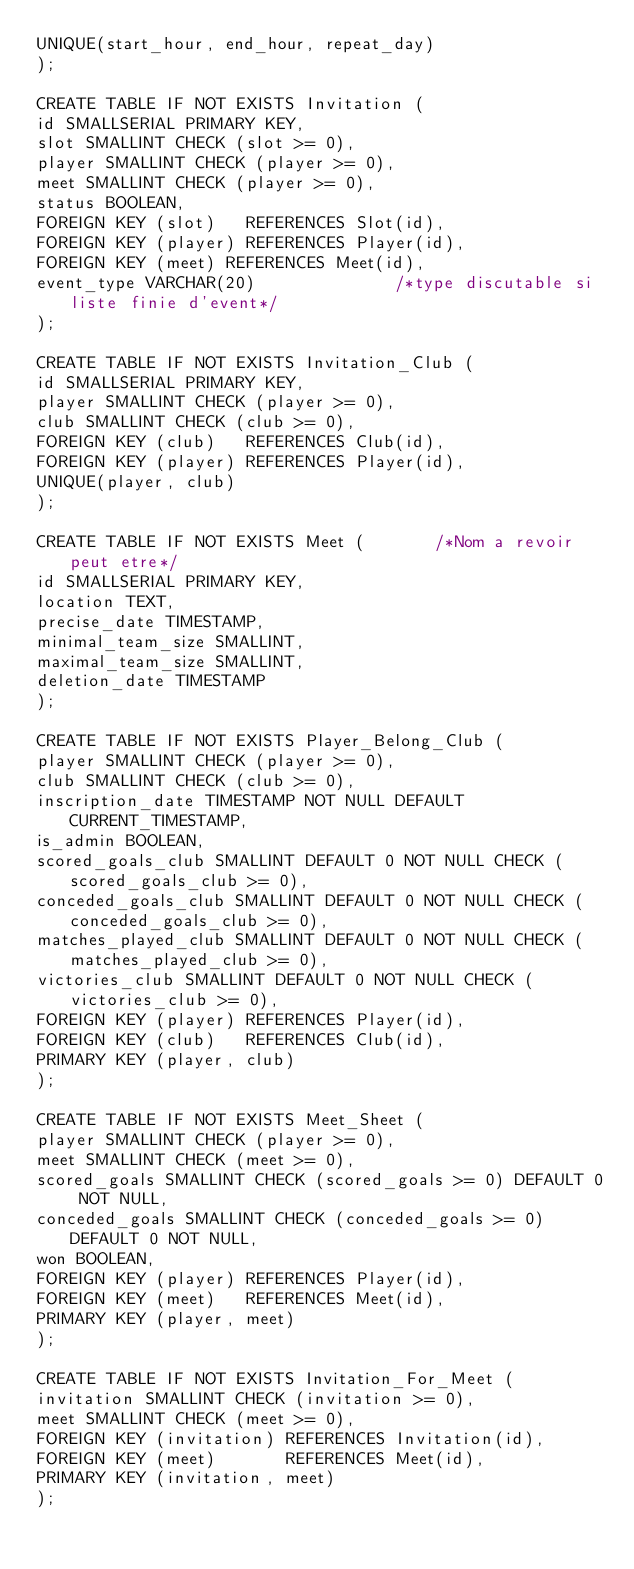<code> <loc_0><loc_0><loc_500><loc_500><_SQL_>UNIQUE(start_hour, end_hour, repeat_day)
);

CREATE TABLE IF NOT EXISTS Invitation (
id SMALLSERIAL PRIMARY KEY,
slot SMALLINT CHECK (slot >= 0),
player SMALLINT CHECK (player >= 0),
meet SMALLINT CHECK (player >= 0),
status BOOLEAN,
FOREIGN KEY (slot)   REFERENCES Slot(id),
FOREIGN KEY (player) REFERENCES Player(id),
FOREIGN KEY (meet) REFERENCES Meet(id),
event_type VARCHAR(20)  						/*type discutable si liste finie d'event*/
);

CREATE TABLE IF NOT EXISTS Invitation_Club (
id SMALLSERIAL PRIMARY KEY,
player SMALLINT CHECK (player >= 0),
club SMALLINT CHECK (club >= 0),
FOREIGN KEY (club)   REFERENCES Club(id),
FOREIGN KEY (player) REFERENCES Player(id),
UNIQUE(player, club)
);

CREATE TABLE IF NOT EXISTS Meet (				/*Nom a revoir peut etre*/
id SMALLSERIAL PRIMARY KEY,
location TEXT,
precise_date TIMESTAMP,
minimal_team_size SMALLINT,
maximal_team_size SMALLINT,
deletion_date TIMESTAMP
);

CREATE TABLE IF NOT EXISTS Player_Belong_Club (
player SMALLINT CHECK (player >= 0),
club SMALLINT CHECK (club >= 0),
inscription_date TIMESTAMP NOT NULL DEFAULT CURRENT_TIMESTAMP,
is_admin BOOLEAN,
scored_goals_club SMALLINT DEFAULT 0 NOT NULL CHECK (scored_goals_club >= 0),
conceded_goals_club SMALLINT DEFAULT 0 NOT NULL CHECK (conceded_goals_club >= 0),
matches_played_club SMALLINT DEFAULT 0 NOT NULL CHECK (matches_played_club >= 0),
victories_club SMALLINT DEFAULT 0 NOT NULL CHECK (victories_club >= 0),
FOREIGN KEY (player) REFERENCES Player(id),
FOREIGN KEY (club)   REFERENCES Club(id),
PRIMARY KEY (player, club)
);

CREATE TABLE IF NOT EXISTS Meet_Sheet (
player SMALLINT CHECK (player >= 0),
meet SMALLINT CHECK (meet >= 0),
scored_goals SMALLINT CHECK (scored_goals >= 0) DEFAULT 0 NOT NULL,
conceded_goals SMALLINT CHECK (conceded_goals >= 0) DEFAULT 0 NOT NULL,
won BOOLEAN,
FOREIGN KEY (player) REFERENCES Player(id),
FOREIGN KEY (meet)   REFERENCES Meet(id),
PRIMARY KEY (player, meet)
);

CREATE TABLE IF NOT EXISTS Invitation_For_Meet (
invitation SMALLINT CHECK (invitation >= 0),
meet SMALLINT CHECK (meet >= 0),
FOREIGN KEY (invitation) REFERENCES Invitation(id),
FOREIGN KEY (meet)       REFERENCES Meet(id),
PRIMARY KEY (invitation, meet)
);
</code> 